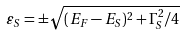<formula> <loc_0><loc_0><loc_500><loc_500>\varepsilon _ { S } = \pm \sqrt { ( E _ { F } - E _ { S } ) ^ { 2 } + \Gamma _ { S } ^ { 2 } / 4 }</formula> 